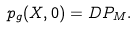Convert formula to latex. <formula><loc_0><loc_0><loc_500><loc_500>p _ { g } ( X , 0 ) = D P _ { M } .</formula> 